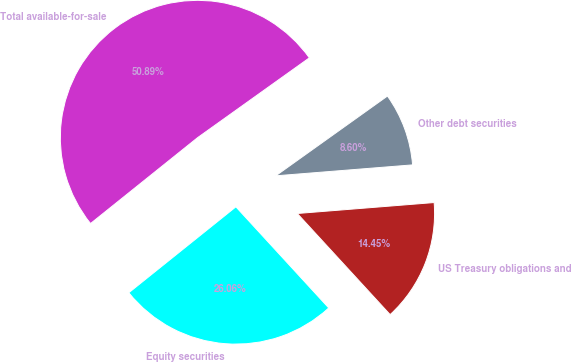<chart> <loc_0><loc_0><loc_500><loc_500><pie_chart><fcel>Equity securities<fcel>US Treasury obligations and<fcel>Other debt securities<fcel>Total available-for-sale<nl><fcel>26.06%<fcel>14.45%<fcel>8.6%<fcel>50.89%<nl></chart> 